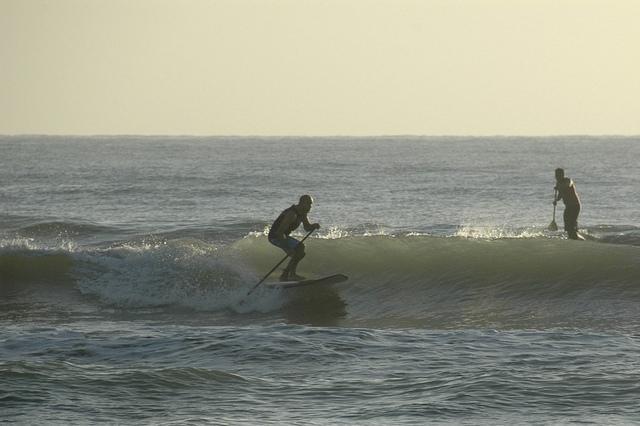How many people are in this photo?
Give a very brief answer. 2. How many people are in the water?
Give a very brief answer. 2. 